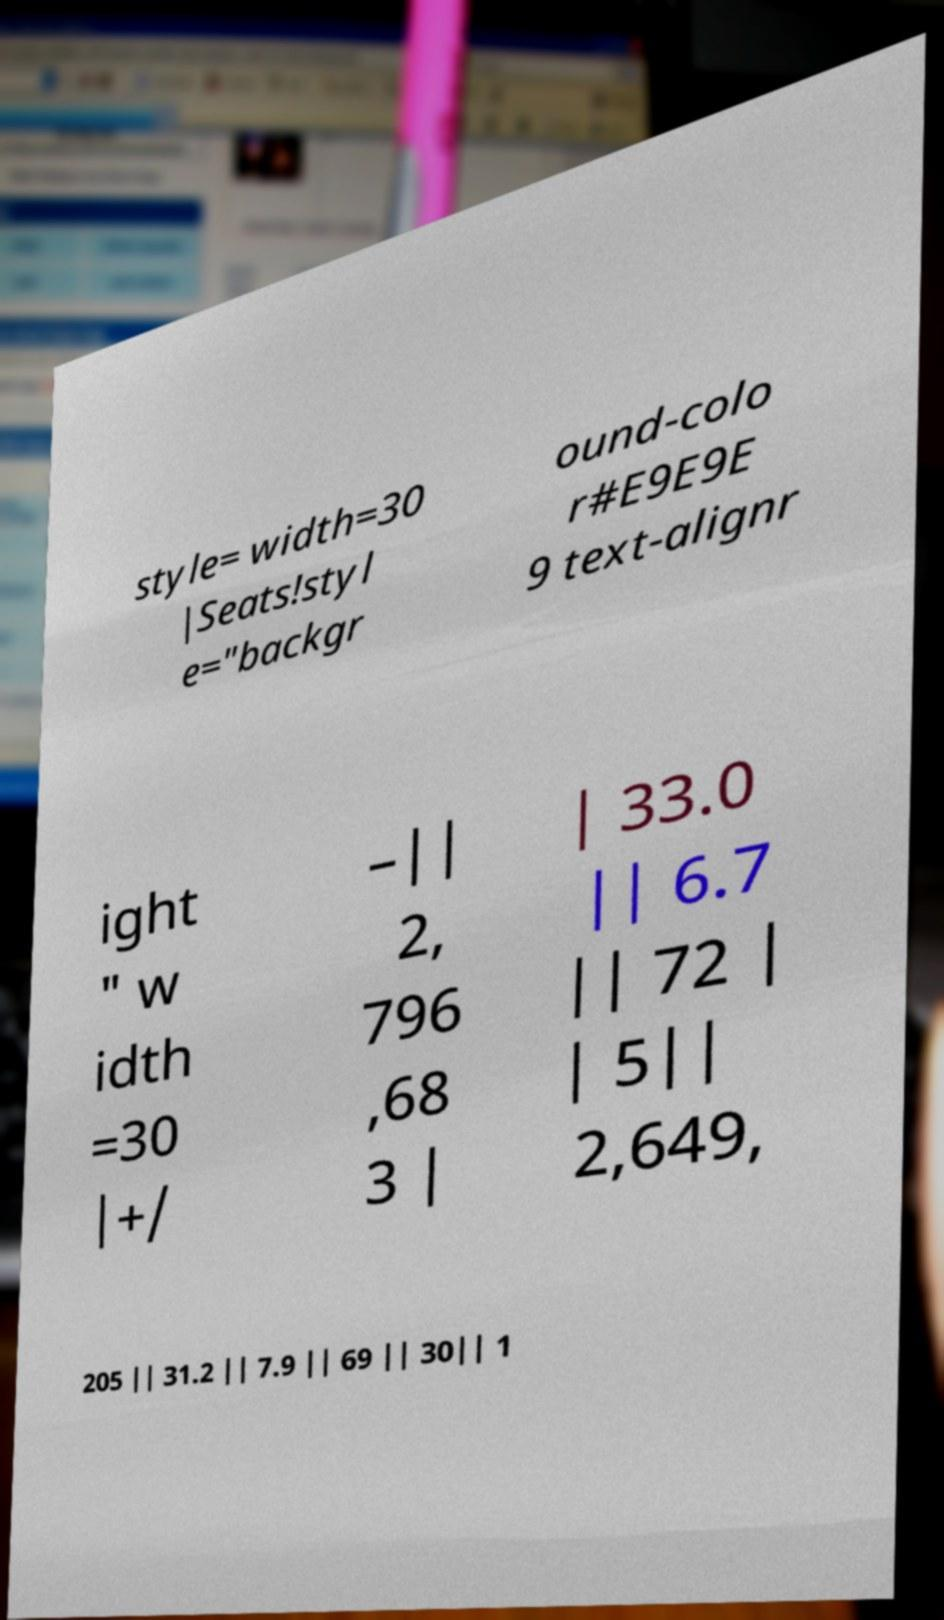I need the written content from this picture converted into text. Can you do that? style= width=30 |Seats!styl e="backgr ound-colo r#E9E9E 9 text-alignr ight " w idth =30 |+/ –|| 2, 796 ,68 3 | | 33.0 || 6.7 || 72 | | 5|| 2,649, 205 || 31.2 || 7.9 || 69 || 30|| 1 